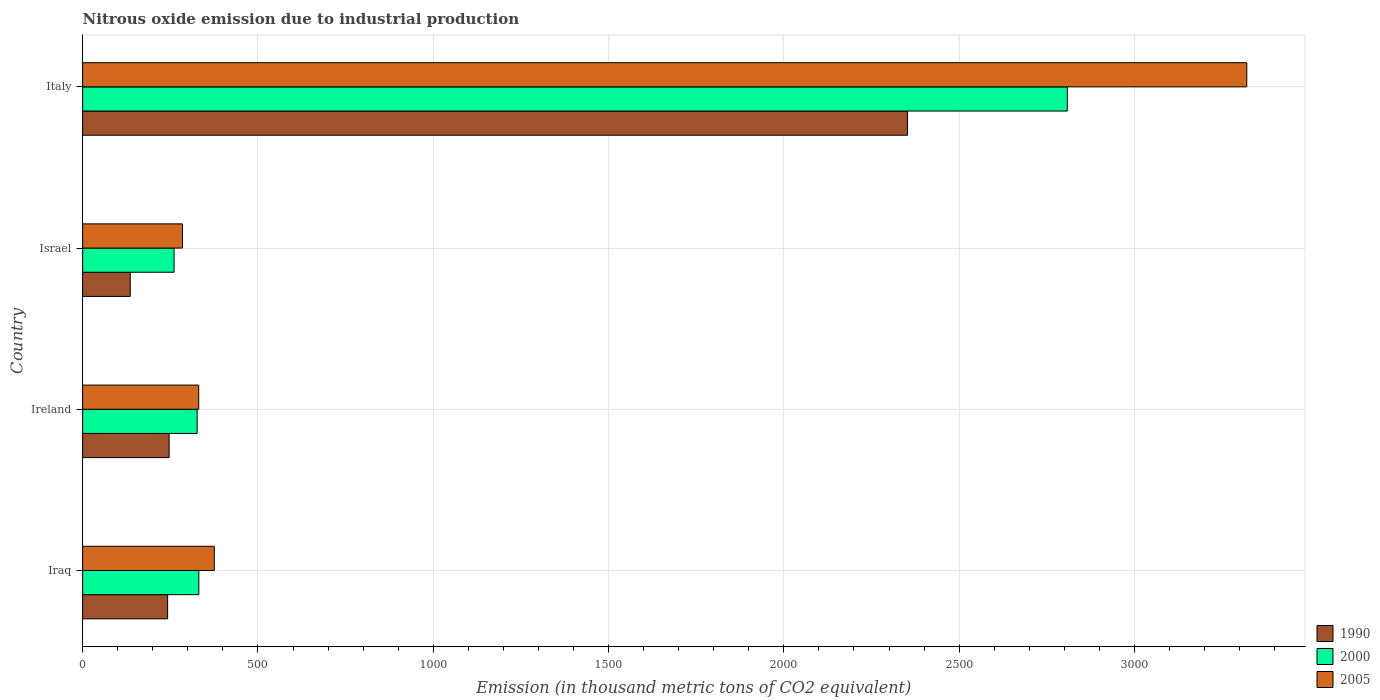How many different coloured bars are there?
Your response must be concise. 3. How many groups of bars are there?
Your response must be concise. 4. Are the number of bars per tick equal to the number of legend labels?
Ensure brevity in your answer.  Yes. What is the label of the 1st group of bars from the top?
Provide a succinct answer. Italy. What is the amount of nitrous oxide emitted in 2005 in Ireland?
Ensure brevity in your answer.  331.1. Across all countries, what is the maximum amount of nitrous oxide emitted in 1990?
Your response must be concise. 2352.7. Across all countries, what is the minimum amount of nitrous oxide emitted in 2005?
Your answer should be compact. 284.9. In which country was the amount of nitrous oxide emitted in 1990 maximum?
Provide a short and direct response. Italy. What is the total amount of nitrous oxide emitted in 2000 in the graph?
Offer a very short reply. 3727.2. What is the difference between the amount of nitrous oxide emitted in 2000 in Ireland and that in Italy?
Provide a short and direct response. -2481.8. What is the difference between the amount of nitrous oxide emitted in 1990 in Italy and the amount of nitrous oxide emitted in 2000 in Ireland?
Your answer should be compact. 2026.1. What is the average amount of nitrous oxide emitted in 1990 per country?
Provide a short and direct response. 744.4. What is the difference between the amount of nitrous oxide emitted in 2005 and amount of nitrous oxide emitted in 1990 in Iraq?
Offer a very short reply. 133.1. In how many countries, is the amount of nitrous oxide emitted in 2000 greater than 2200 thousand metric tons?
Offer a very short reply. 1. What is the ratio of the amount of nitrous oxide emitted in 1990 in Iraq to that in Ireland?
Offer a terse response. 0.98. Is the difference between the amount of nitrous oxide emitted in 2005 in Ireland and Israel greater than the difference between the amount of nitrous oxide emitted in 1990 in Ireland and Israel?
Make the answer very short. No. What is the difference between the highest and the second highest amount of nitrous oxide emitted in 2005?
Make the answer very short. 2944.8. What is the difference between the highest and the lowest amount of nitrous oxide emitted in 1990?
Provide a succinct answer. 2216.9. In how many countries, is the amount of nitrous oxide emitted in 1990 greater than the average amount of nitrous oxide emitted in 1990 taken over all countries?
Ensure brevity in your answer.  1. Is the sum of the amount of nitrous oxide emitted in 2000 in Iraq and Ireland greater than the maximum amount of nitrous oxide emitted in 1990 across all countries?
Ensure brevity in your answer.  No. What does the 1st bar from the top in Italy represents?
Provide a succinct answer. 2005. What does the 2nd bar from the bottom in Ireland represents?
Offer a terse response. 2000. How many bars are there?
Offer a very short reply. 12. Are all the bars in the graph horizontal?
Your response must be concise. Yes. How many countries are there in the graph?
Your answer should be very brief. 4. Does the graph contain grids?
Provide a short and direct response. Yes. How many legend labels are there?
Keep it short and to the point. 3. How are the legend labels stacked?
Provide a succinct answer. Vertical. What is the title of the graph?
Provide a short and direct response. Nitrous oxide emission due to industrial production. Does "1991" appear as one of the legend labels in the graph?
Offer a very short reply. No. What is the label or title of the X-axis?
Keep it short and to the point. Emission (in thousand metric tons of CO2 equivalent). What is the label or title of the Y-axis?
Make the answer very short. Country. What is the Emission (in thousand metric tons of CO2 equivalent) in 1990 in Iraq?
Give a very brief answer. 242.4. What is the Emission (in thousand metric tons of CO2 equivalent) in 2000 in Iraq?
Your answer should be very brief. 331.4. What is the Emission (in thousand metric tons of CO2 equivalent) in 2005 in Iraq?
Your answer should be compact. 375.5. What is the Emission (in thousand metric tons of CO2 equivalent) in 1990 in Ireland?
Offer a terse response. 246.7. What is the Emission (in thousand metric tons of CO2 equivalent) in 2000 in Ireland?
Give a very brief answer. 326.6. What is the Emission (in thousand metric tons of CO2 equivalent) in 2005 in Ireland?
Your response must be concise. 331.1. What is the Emission (in thousand metric tons of CO2 equivalent) in 1990 in Israel?
Offer a very short reply. 135.8. What is the Emission (in thousand metric tons of CO2 equivalent) in 2000 in Israel?
Give a very brief answer. 260.8. What is the Emission (in thousand metric tons of CO2 equivalent) of 2005 in Israel?
Your response must be concise. 284.9. What is the Emission (in thousand metric tons of CO2 equivalent) of 1990 in Italy?
Offer a very short reply. 2352.7. What is the Emission (in thousand metric tons of CO2 equivalent) of 2000 in Italy?
Provide a short and direct response. 2808.4. What is the Emission (in thousand metric tons of CO2 equivalent) of 2005 in Italy?
Your answer should be very brief. 3320.3. Across all countries, what is the maximum Emission (in thousand metric tons of CO2 equivalent) in 1990?
Keep it short and to the point. 2352.7. Across all countries, what is the maximum Emission (in thousand metric tons of CO2 equivalent) of 2000?
Provide a short and direct response. 2808.4. Across all countries, what is the maximum Emission (in thousand metric tons of CO2 equivalent) of 2005?
Ensure brevity in your answer.  3320.3. Across all countries, what is the minimum Emission (in thousand metric tons of CO2 equivalent) of 1990?
Offer a terse response. 135.8. Across all countries, what is the minimum Emission (in thousand metric tons of CO2 equivalent) of 2000?
Offer a very short reply. 260.8. Across all countries, what is the minimum Emission (in thousand metric tons of CO2 equivalent) in 2005?
Keep it short and to the point. 284.9. What is the total Emission (in thousand metric tons of CO2 equivalent) of 1990 in the graph?
Your answer should be compact. 2977.6. What is the total Emission (in thousand metric tons of CO2 equivalent) in 2000 in the graph?
Offer a terse response. 3727.2. What is the total Emission (in thousand metric tons of CO2 equivalent) of 2005 in the graph?
Provide a short and direct response. 4311.8. What is the difference between the Emission (in thousand metric tons of CO2 equivalent) in 2005 in Iraq and that in Ireland?
Ensure brevity in your answer.  44.4. What is the difference between the Emission (in thousand metric tons of CO2 equivalent) in 1990 in Iraq and that in Israel?
Your answer should be compact. 106.6. What is the difference between the Emission (in thousand metric tons of CO2 equivalent) in 2000 in Iraq and that in Israel?
Make the answer very short. 70.6. What is the difference between the Emission (in thousand metric tons of CO2 equivalent) in 2005 in Iraq and that in Israel?
Your response must be concise. 90.6. What is the difference between the Emission (in thousand metric tons of CO2 equivalent) of 1990 in Iraq and that in Italy?
Your answer should be very brief. -2110.3. What is the difference between the Emission (in thousand metric tons of CO2 equivalent) of 2000 in Iraq and that in Italy?
Give a very brief answer. -2477. What is the difference between the Emission (in thousand metric tons of CO2 equivalent) in 2005 in Iraq and that in Italy?
Ensure brevity in your answer.  -2944.8. What is the difference between the Emission (in thousand metric tons of CO2 equivalent) of 1990 in Ireland and that in Israel?
Make the answer very short. 110.9. What is the difference between the Emission (in thousand metric tons of CO2 equivalent) in 2000 in Ireland and that in Israel?
Keep it short and to the point. 65.8. What is the difference between the Emission (in thousand metric tons of CO2 equivalent) of 2005 in Ireland and that in Israel?
Ensure brevity in your answer.  46.2. What is the difference between the Emission (in thousand metric tons of CO2 equivalent) in 1990 in Ireland and that in Italy?
Ensure brevity in your answer.  -2106. What is the difference between the Emission (in thousand metric tons of CO2 equivalent) in 2000 in Ireland and that in Italy?
Offer a very short reply. -2481.8. What is the difference between the Emission (in thousand metric tons of CO2 equivalent) of 2005 in Ireland and that in Italy?
Provide a succinct answer. -2989.2. What is the difference between the Emission (in thousand metric tons of CO2 equivalent) in 1990 in Israel and that in Italy?
Offer a very short reply. -2216.9. What is the difference between the Emission (in thousand metric tons of CO2 equivalent) of 2000 in Israel and that in Italy?
Provide a short and direct response. -2547.6. What is the difference between the Emission (in thousand metric tons of CO2 equivalent) of 2005 in Israel and that in Italy?
Offer a very short reply. -3035.4. What is the difference between the Emission (in thousand metric tons of CO2 equivalent) in 1990 in Iraq and the Emission (in thousand metric tons of CO2 equivalent) in 2000 in Ireland?
Keep it short and to the point. -84.2. What is the difference between the Emission (in thousand metric tons of CO2 equivalent) of 1990 in Iraq and the Emission (in thousand metric tons of CO2 equivalent) of 2005 in Ireland?
Offer a very short reply. -88.7. What is the difference between the Emission (in thousand metric tons of CO2 equivalent) of 2000 in Iraq and the Emission (in thousand metric tons of CO2 equivalent) of 2005 in Ireland?
Keep it short and to the point. 0.3. What is the difference between the Emission (in thousand metric tons of CO2 equivalent) of 1990 in Iraq and the Emission (in thousand metric tons of CO2 equivalent) of 2000 in Israel?
Your answer should be very brief. -18.4. What is the difference between the Emission (in thousand metric tons of CO2 equivalent) of 1990 in Iraq and the Emission (in thousand metric tons of CO2 equivalent) of 2005 in Israel?
Offer a very short reply. -42.5. What is the difference between the Emission (in thousand metric tons of CO2 equivalent) in 2000 in Iraq and the Emission (in thousand metric tons of CO2 equivalent) in 2005 in Israel?
Make the answer very short. 46.5. What is the difference between the Emission (in thousand metric tons of CO2 equivalent) in 1990 in Iraq and the Emission (in thousand metric tons of CO2 equivalent) in 2000 in Italy?
Keep it short and to the point. -2566. What is the difference between the Emission (in thousand metric tons of CO2 equivalent) of 1990 in Iraq and the Emission (in thousand metric tons of CO2 equivalent) of 2005 in Italy?
Give a very brief answer. -3077.9. What is the difference between the Emission (in thousand metric tons of CO2 equivalent) in 2000 in Iraq and the Emission (in thousand metric tons of CO2 equivalent) in 2005 in Italy?
Your answer should be very brief. -2988.9. What is the difference between the Emission (in thousand metric tons of CO2 equivalent) of 1990 in Ireland and the Emission (in thousand metric tons of CO2 equivalent) of 2000 in Israel?
Make the answer very short. -14.1. What is the difference between the Emission (in thousand metric tons of CO2 equivalent) in 1990 in Ireland and the Emission (in thousand metric tons of CO2 equivalent) in 2005 in Israel?
Offer a very short reply. -38.2. What is the difference between the Emission (in thousand metric tons of CO2 equivalent) in 2000 in Ireland and the Emission (in thousand metric tons of CO2 equivalent) in 2005 in Israel?
Your answer should be compact. 41.7. What is the difference between the Emission (in thousand metric tons of CO2 equivalent) of 1990 in Ireland and the Emission (in thousand metric tons of CO2 equivalent) of 2000 in Italy?
Offer a very short reply. -2561.7. What is the difference between the Emission (in thousand metric tons of CO2 equivalent) in 1990 in Ireland and the Emission (in thousand metric tons of CO2 equivalent) in 2005 in Italy?
Give a very brief answer. -3073.6. What is the difference between the Emission (in thousand metric tons of CO2 equivalent) in 2000 in Ireland and the Emission (in thousand metric tons of CO2 equivalent) in 2005 in Italy?
Offer a terse response. -2993.7. What is the difference between the Emission (in thousand metric tons of CO2 equivalent) of 1990 in Israel and the Emission (in thousand metric tons of CO2 equivalent) of 2000 in Italy?
Keep it short and to the point. -2672.6. What is the difference between the Emission (in thousand metric tons of CO2 equivalent) of 1990 in Israel and the Emission (in thousand metric tons of CO2 equivalent) of 2005 in Italy?
Your answer should be very brief. -3184.5. What is the difference between the Emission (in thousand metric tons of CO2 equivalent) in 2000 in Israel and the Emission (in thousand metric tons of CO2 equivalent) in 2005 in Italy?
Your response must be concise. -3059.5. What is the average Emission (in thousand metric tons of CO2 equivalent) of 1990 per country?
Keep it short and to the point. 744.4. What is the average Emission (in thousand metric tons of CO2 equivalent) of 2000 per country?
Keep it short and to the point. 931.8. What is the average Emission (in thousand metric tons of CO2 equivalent) of 2005 per country?
Keep it short and to the point. 1077.95. What is the difference between the Emission (in thousand metric tons of CO2 equivalent) of 1990 and Emission (in thousand metric tons of CO2 equivalent) of 2000 in Iraq?
Provide a succinct answer. -89. What is the difference between the Emission (in thousand metric tons of CO2 equivalent) of 1990 and Emission (in thousand metric tons of CO2 equivalent) of 2005 in Iraq?
Your response must be concise. -133.1. What is the difference between the Emission (in thousand metric tons of CO2 equivalent) of 2000 and Emission (in thousand metric tons of CO2 equivalent) of 2005 in Iraq?
Keep it short and to the point. -44.1. What is the difference between the Emission (in thousand metric tons of CO2 equivalent) in 1990 and Emission (in thousand metric tons of CO2 equivalent) in 2000 in Ireland?
Provide a short and direct response. -79.9. What is the difference between the Emission (in thousand metric tons of CO2 equivalent) of 1990 and Emission (in thousand metric tons of CO2 equivalent) of 2005 in Ireland?
Provide a short and direct response. -84.4. What is the difference between the Emission (in thousand metric tons of CO2 equivalent) in 2000 and Emission (in thousand metric tons of CO2 equivalent) in 2005 in Ireland?
Your answer should be very brief. -4.5. What is the difference between the Emission (in thousand metric tons of CO2 equivalent) in 1990 and Emission (in thousand metric tons of CO2 equivalent) in 2000 in Israel?
Your answer should be very brief. -125. What is the difference between the Emission (in thousand metric tons of CO2 equivalent) in 1990 and Emission (in thousand metric tons of CO2 equivalent) in 2005 in Israel?
Your answer should be very brief. -149.1. What is the difference between the Emission (in thousand metric tons of CO2 equivalent) in 2000 and Emission (in thousand metric tons of CO2 equivalent) in 2005 in Israel?
Offer a terse response. -24.1. What is the difference between the Emission (in thousand metric tons of CO2 equivalent) in 1990 and Emission (in thousand metric tons of CO2 equivalent) in 2000 in Italy?
Offer a very short reply. -455.7. What is the difference between the Emission (in thousand metric tons of CO2 equivalent) in 1990 and Emission (in thousand metric tons of CO2 equivalent) in 2005 in Italy?
Provide a succinct answer. -967.6. What is the difference between the Emission (in thousand metric tons of CO2 equivalent) in 2000 and Emission (in thousand metric tons of CO2 equivalent) in 2005 in Italy?
Give a very brief answer. -511.9. What is the ratio of the Emission (in thousand metric tons of CO2 equivalent) of 1990 in Iraq to that in Ireland?
Ensure brevity in your answer.  0.98. What is the ratio of the Emission (in thousand metric tons of CO2 equivalent) of 2000 in Iraq to that in Ireland?
Give a very brief answer. 1.01. What is the ratio of the Emission (in thousand metric tons of CO2 equivalent) of 2005 in Iraq to that in Ireland?
Your response must be concise. 1.13. What is the ratio of the Emission (in thousand metric tons of CO2 equivalent) of 1990 in Iraq to that in Israel?
Keep it short and to the point. 1.78. What is the ratio of the Emission (in thousand metric tons of CO2 equivalent) of 2000 in Iraq to that in Israel?
Your response must be concise. 1.27. What is the ratio of the Emission (in thousand metric tons of CO2 equivalent) in 2005 in Iraq to that in Israel?
Your answer should be compact. 1.32. What is the ratio of the Emission (in thousand metric tons of CO2 equivalent) in 1990 in Iraq to that in Italy?
Ensure brevity in your answer.  0.1. What is the ratio of the Emission (in thousand metric tons of CO2 equivalent) of 2000 in Iraq to that in Italy?
Make the answer very short. 0.12. What is the ratio of the Emission (in thousand metric tons of CO2 equivalent) of 2005 in Iraq to that in Italy?
Offer a very short reply. 0.11. What is the ratio of the Emission (in thousand metric tons of CO2 equivalent) in 1990 in Ireland to that in Israel?
Offer a very short reply. 1.82. What is the ratio of the Emission (in thousand metric tons of CO2 equivalent) in 2000 in Ireland to that in Israel?
Your answer should be compact. 1.25. What is the ratio of the Emission (in thousand metric tons of CO2 equivalent) of 2005 in Ireland to that in Israel?
Your answer should be compact. 1.16. What is the ratio of the Emission (in thousand metric tons of CO2 equivalent) in 1990 in Ireland to that in Italy?
Your response must be concise. 0.1. What is the ratio of the Emission (in thousand metric tons of CO2 equivalent) of 2000 in Ireland to that in Italy?
Provide a succinct answer. 0.12. What is the ratio of the Emission (in thousand metric tons of CO2 equivalent) in 2005 in Ireland to that in Italy?
Your answer should be very brief. 0.1. What is the ratio of the Emission (in thousand metric tons of CO2 equivalent) of 1990 in Israel to that in Italy?
Provide a succinct answer. 0.06. What is the ratio of the Emission (in thousand metric tons of CO2 equivalent) of 2000 in Israel to that in Italy?
Provide a short and direct response. 0.09. What is the ratio of the Emission (in thousand metric tons of CO2 equivalent) of 2005 in Israel to that in Italy?
Provide a short and direct response. 0.09. What is the difference between the highest and the second highest Emission (in thousand metric tons of CO2 equivalent) of 1990?
Make the answer very short. 2106. What is the difference between the highest and the second highest Emission (in thousand metric tons of CO2 equivalent) of 2000?
Offer a terse response. 2477. What is the difference between the highest and the second highest Emission (in thousand metric tons of CO2 equivalent) in 2005?
Ensure brevity in your answer.  2944.8. What is the difference between the highest and the lowest Emission (in thousand metric tons of CO2 equivalent) in 1990?
Your answer should be compact. 2216.9. What is the difference between the highest and the lowest Emission (in thousand metric tons of CO2 equivalent) of 2000?
Offer a terse response. 2547.6. What is the difference between the highest and the lowest Emission (in thousand metric tons of CO2 equivalent) of 2005?
Keep it short and to the point. 3035.4. 